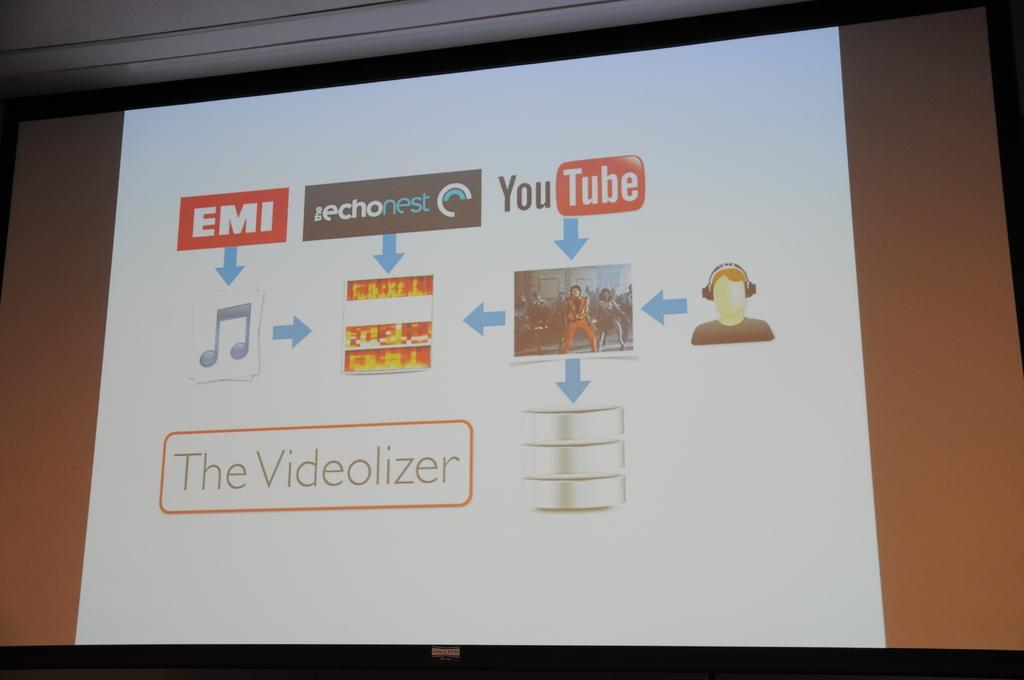Can you describe this image briefly? It is a zoom in picture of a big screen and on the screen there is an EMI, youtube, music icon, person with headsets and these all are followed by directions. 